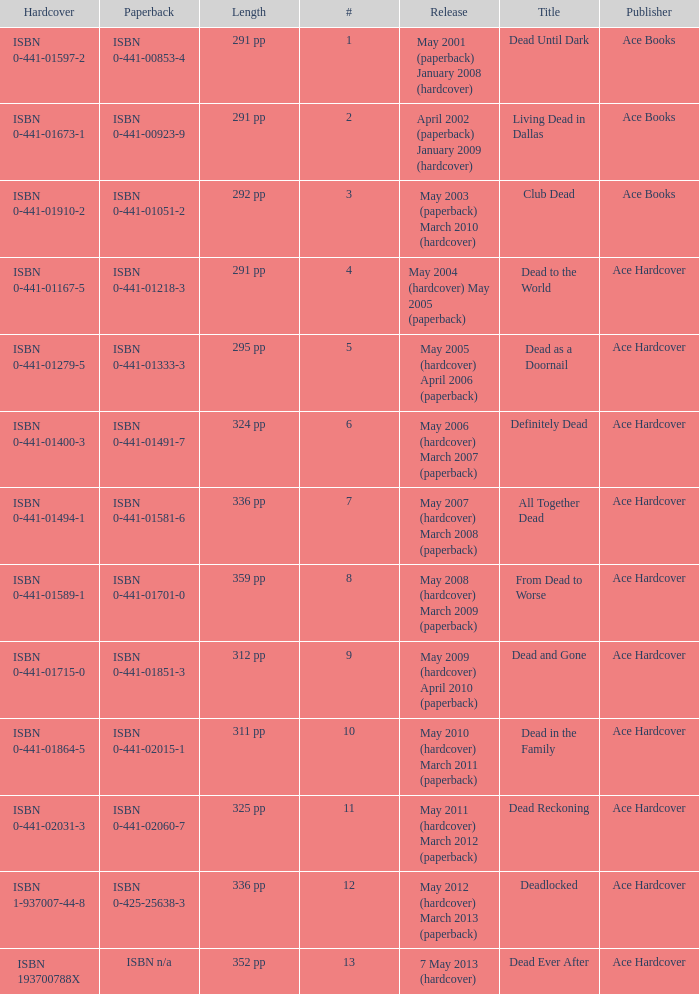Isbn 0-441-01400-3 is book number? 6.0. 